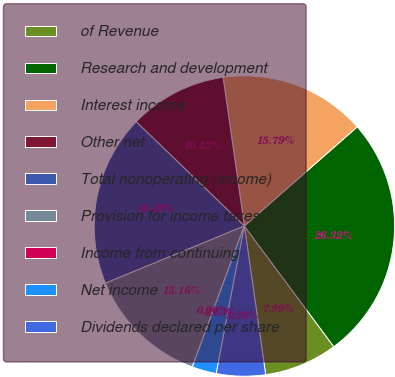Convert chart to OTSL. <chart><loc_0><loc_0><loc_500><loc_500><pie_chart><fcel>of Revenue<fcel>Research and development<fcel>Interest income<fcel>Other net<fcel>Total nonoperating (income)<fcel>Provision for income taxes<fcel>Income from continuing<fcel>Net income<fcel>Dividends declared per share<nl><fcel>7.89%<fcel>26.32%<fcel>15.79%<fcel>10.53%<fcel>18.42%<fcel>13.16%<fcel>0.0%<fcel>2.63%<fcel>5.26%<nl></chart> 